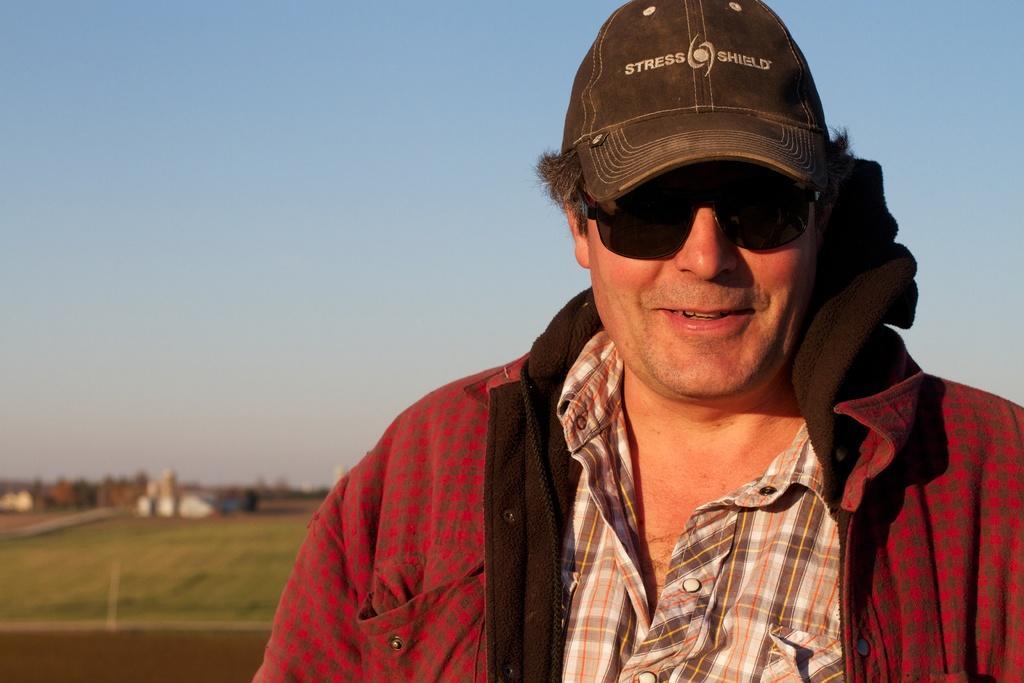In one or two sentences, can you explain what this image depicts? In the picture we can see a man standing, he is wearing a red shirt with checks and same another shirt inside and wearing a cap, which is black in color and in the background, we can see a grass surface on it we can some houses and behind we can see a sky. 